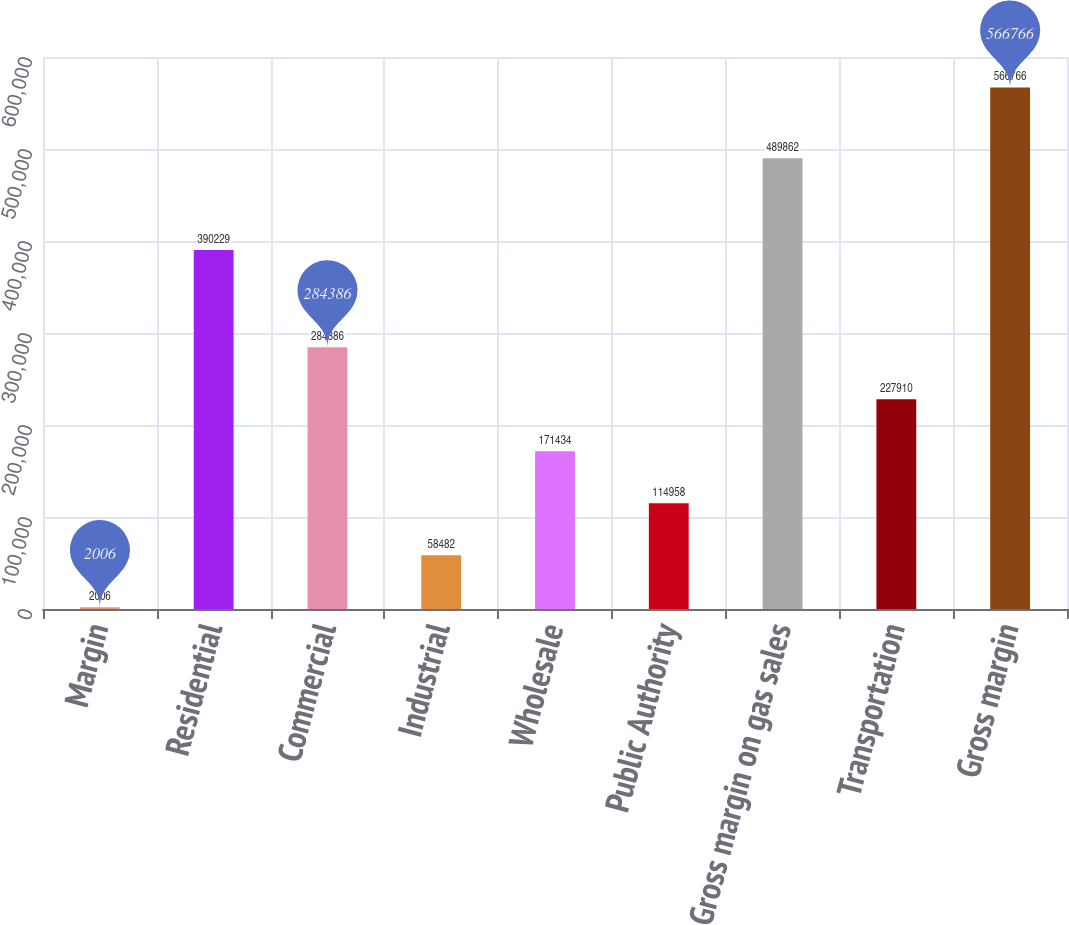<chart> <loc_0><loc_0><loc_500><loc_500><bar_chart><fcel>Margin<fcel>Residential<fcel>Commercial<fcel>Industrial<fcel>Wholesale<fcel>Public Authority<fcel>Gross margin on gas sales<fcel>Transportation<fcel>Gross margin<nl><fcel>2006<fcel>390229<fcel>284386<fcel>58482<fcel>171434<fcel>114958<fcel>489862<fcel>227910<fcel>566766<nl></chart> 